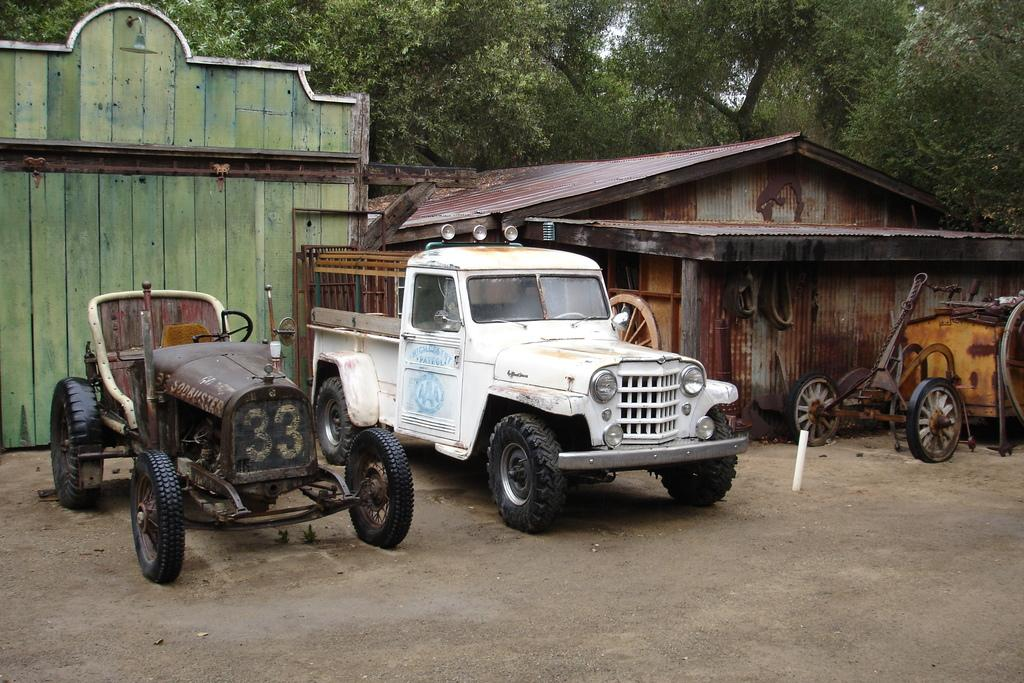What is located in the center of the image? There are three vehicles in the center of the image. What can be seen in the background of the image? There is sky, trees, a shed, a wooden wall, and a few other objects visible in the background of the image. How many vehicles are present in the image? There are three vehicles in the image. What type of flock can be seen flying over the vehicles in the image? There is no flock of birds or any other animals visible in the image. Is there a water source visible in the image? No, there is no water source visible in the image. 